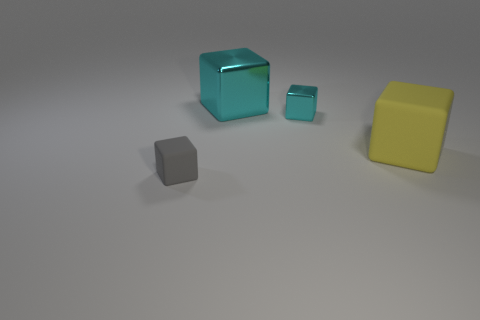Do the big cyan cube and the small cyan cube have the same material?
Provide a succinct answer. Yes. There is a matte thing that is on the right side of the matte cube that is on the left side of the matte object behind the tiny gray rubber block; what shape is it?
Your answer should be compact. Cube. Are there fewer blocks that are left of the gray matte object than large cubes behind the small shiny cube?
Your response must be concise. Yes. What is the shape of the tiny thing that is in front of the big object in front of the big shiny object?
Keep it short and to the point. Cube. Is there any other thing of the same color as the big matte cube?
Your answer should be compact. No. Is the small metal object the same color as the big metal object?
Ensure brevity in your answer.  Yes. How many cyan things are large blocks or big metal objects?
Your answer should be compact. 1. Is the number of small cyan objects on the right side of the tiny metallic block less than the number of rubber spheres?
Your answer should be very brief. No. What number of cubes are on the right side of the small matte object in front of the yellow cube?
Keep it short and to the point. 3. How many other things are there of the same size as the yellow block?
Offer a terse response. 1. 